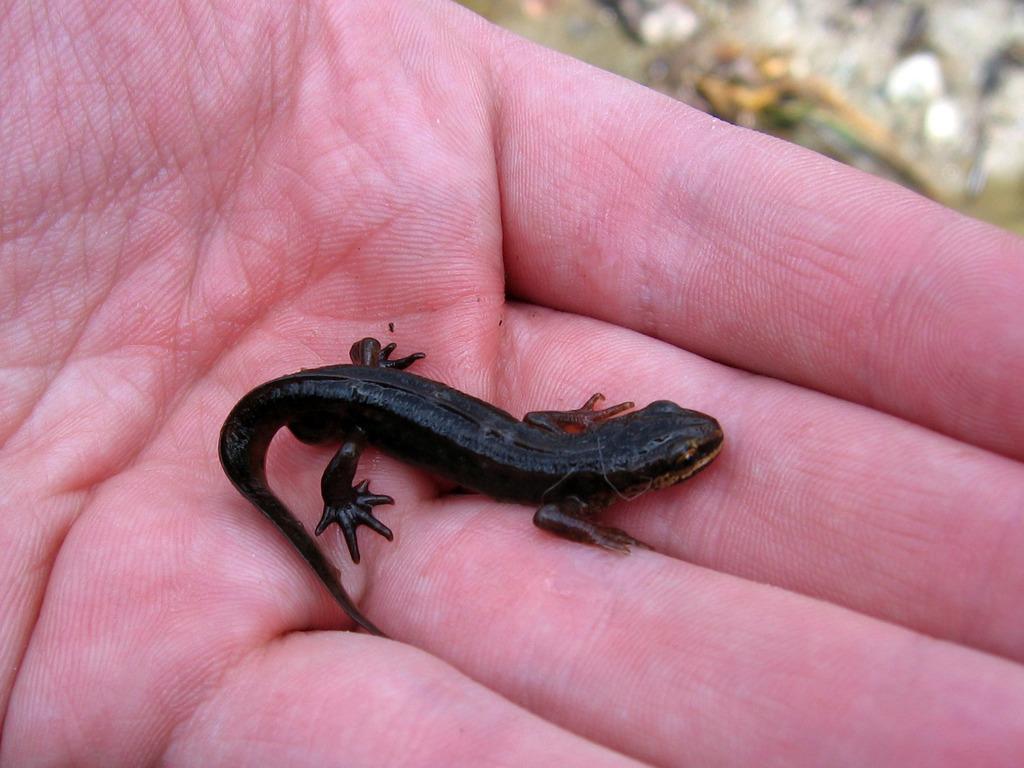Can you describe this image briefly? This picture contains a black color lizard placed in the hand of a human. In the right top of the picture, it is blurred. 